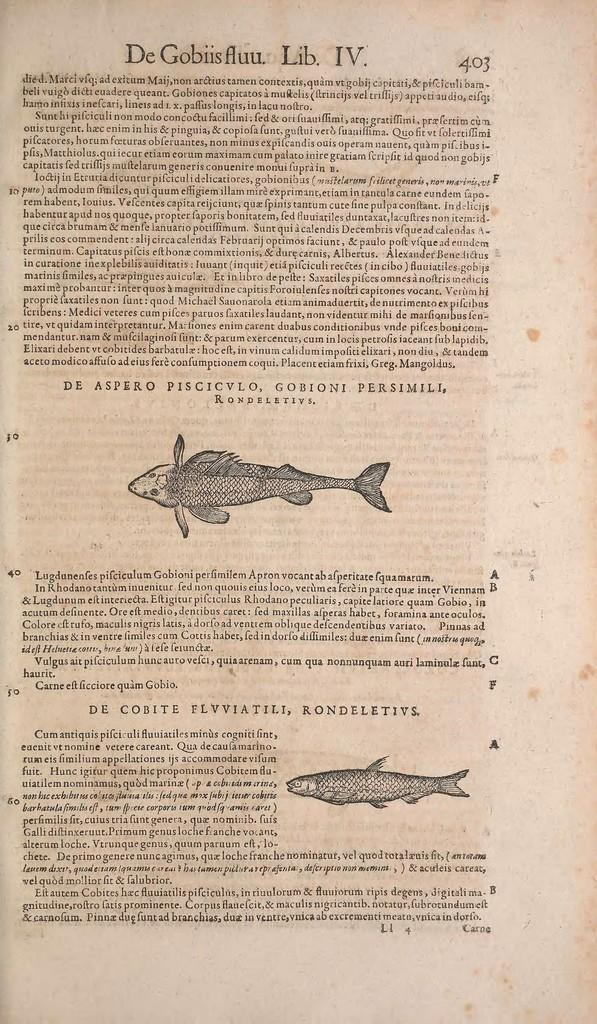What type of animals are depicted in the images in the picture? There are pictures of fish in the image. What else can be seen in the image besides the pictures of fish? There is text on a paper in the image. Where is the nearest playground to the location depicted in the image? The image does not provide any information about the location, so it is impossible to determine the nearest playground. 